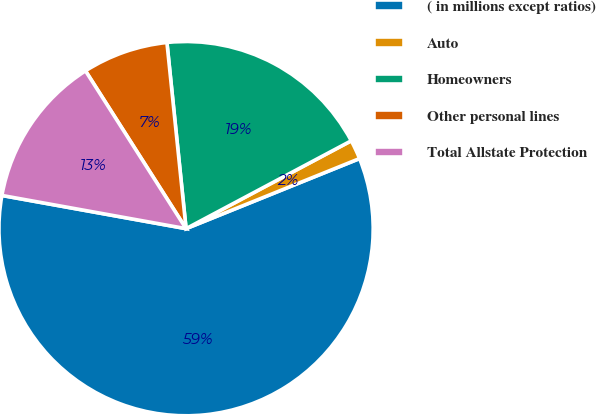<chart> <loc_0><loc_0><loc_500><loc_500><pie_chart><fcel>( in millions except ratios)<fcel>Auto<fcel>Homeowners<fcel>Other personal lines<fcel>Total Allstate Protection<nl><fcel>58.95%<fcel>1.67%<fcel>18.85%<fcel>7.4%<fcel>13.13%<nl></chart> 